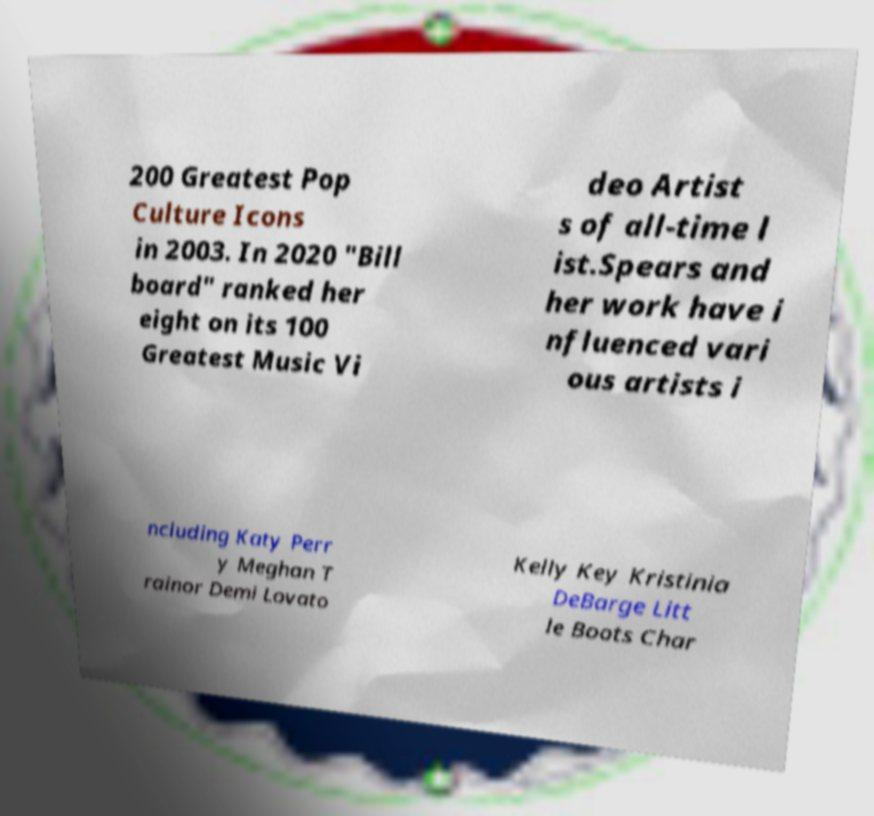I need the written content from this picture converted into text. Can you do that? 200 Greatest Pop Culture Icons in 2003. In 2020 "Bill board" ranked her eight on its 100 Greatest Music Vi deo Artist s of all-time l ist.Spears and her work have i nfluenced vari ous artists i ncluding Katy Perr y Meghan T rainor Demi Lovato Kelly Key Kristinia DeBarge Litt le Boots Char 